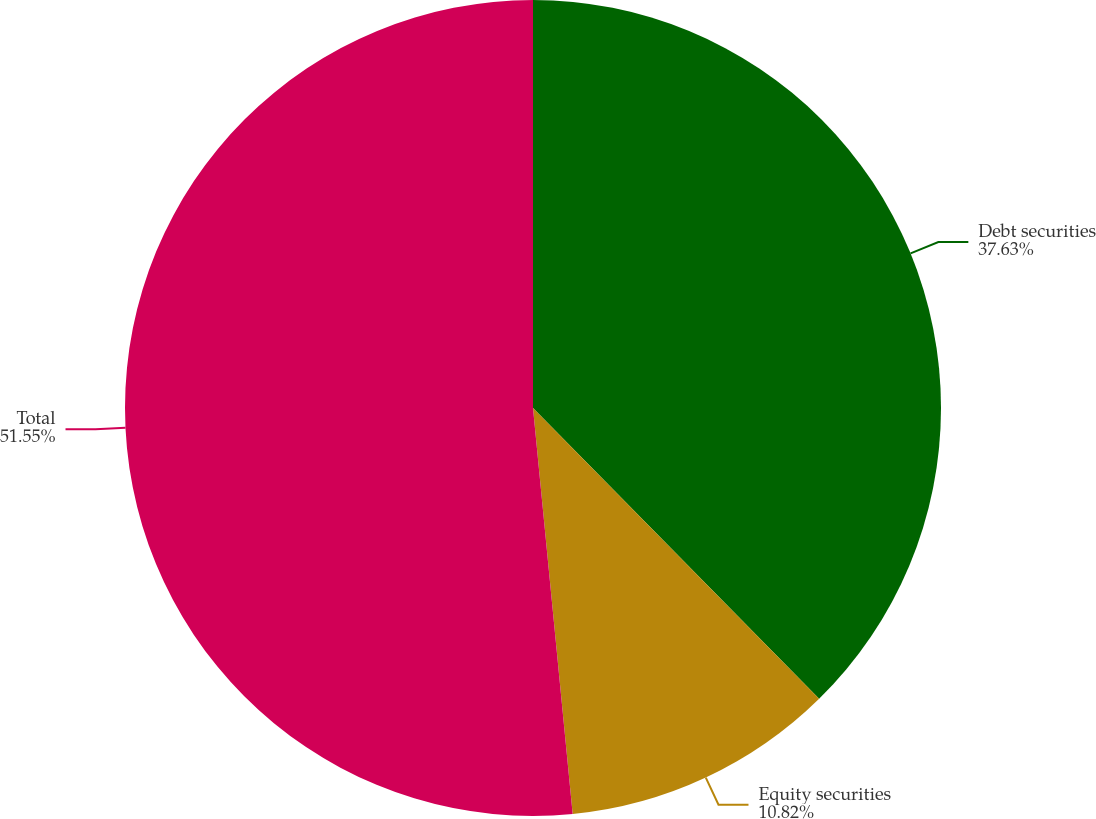Convert chart. <chart><loc_0><loc_0><loc_500><loc_500><pie_chart><fcel>Debt securities<fcel>Equity securities<fcel>Total<nl><fcel>37.63%<fcel>10.82%<fcel>51.55%<nl></chart> 